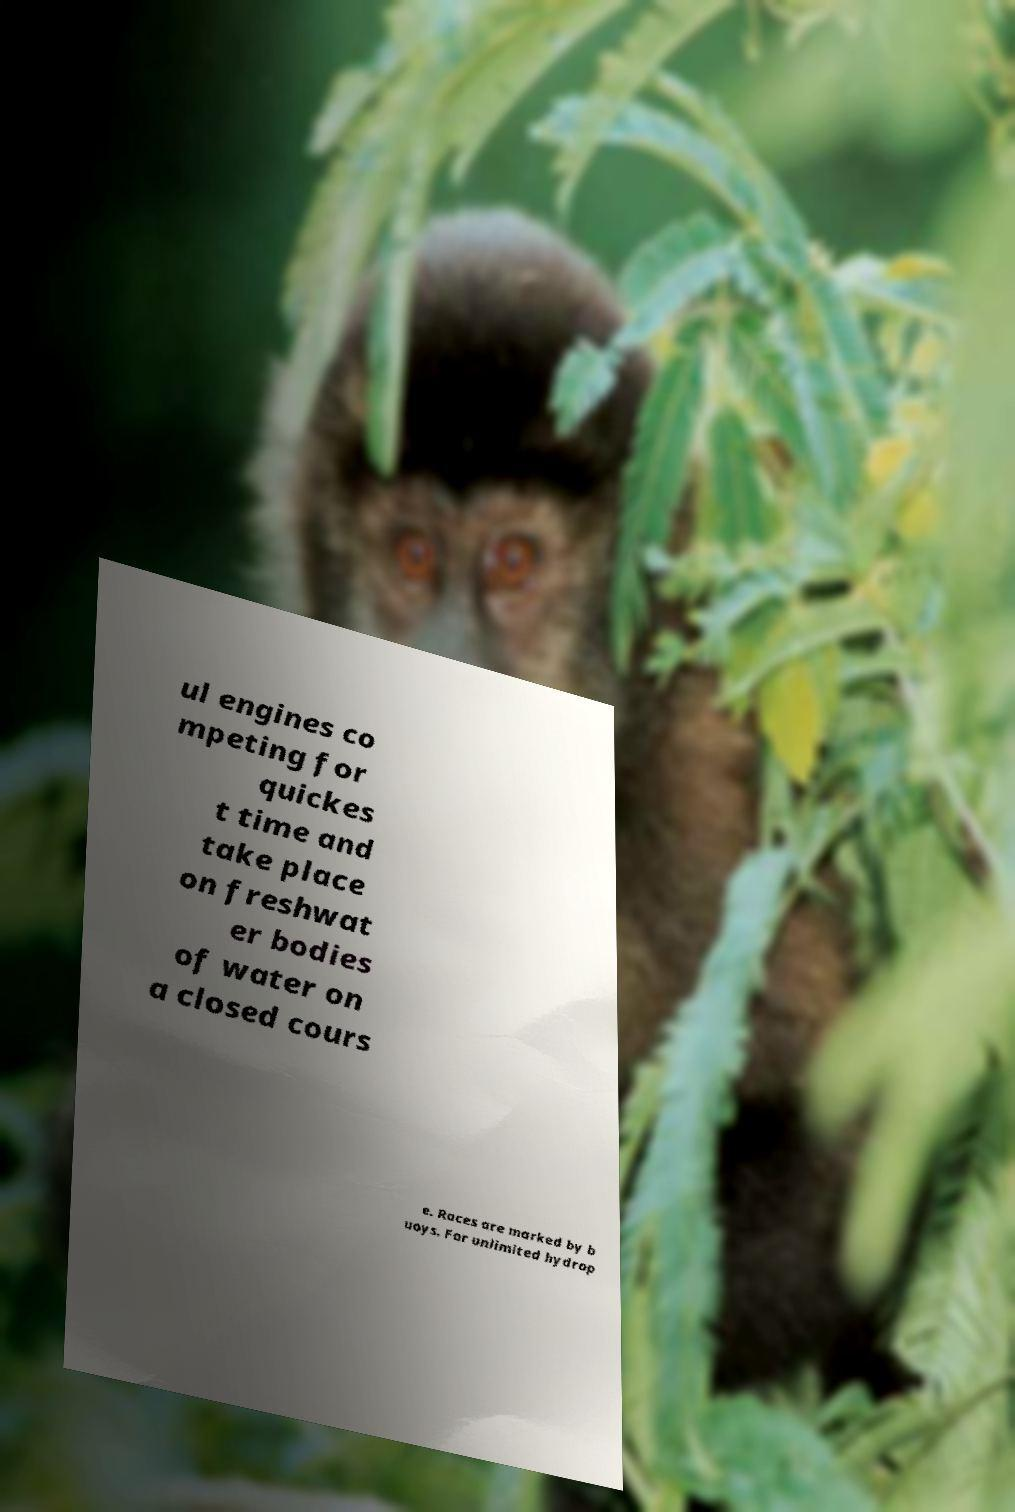I need the written content from this picture converted into text. Can you do that? ul engines co mpeting for quickes t time and take place on freshwat er bodies of water on a closed cours e. Races are marked by b uoys. For unlimited hydrop 